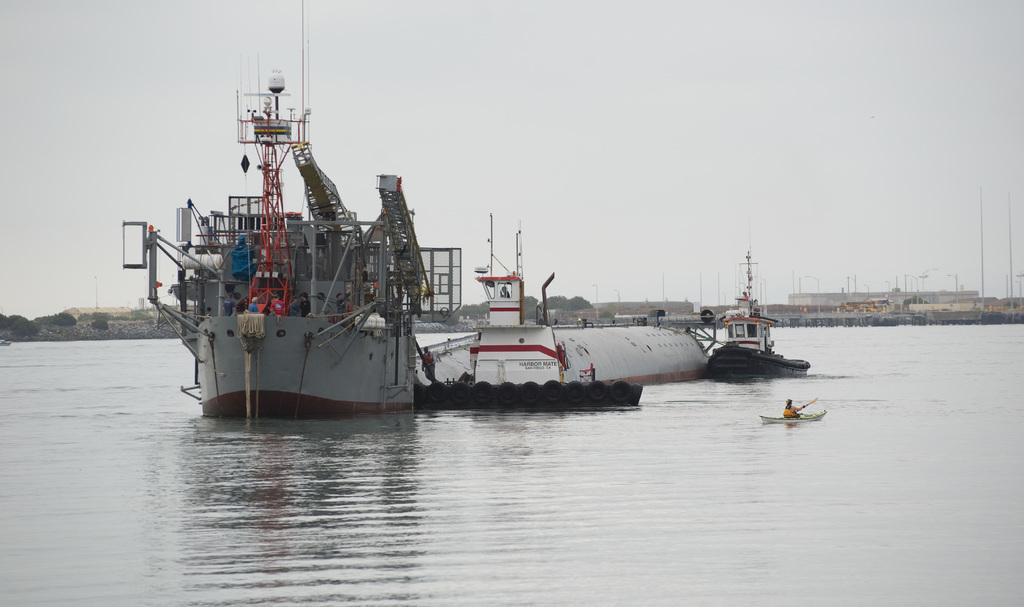What is the main subject of the image? There is a ship in the image. Where is the ship located? The ship is on the water. What can be seen in the background of the image? There are buildings and trees with green color in the background of the image. How is the sky depicted in the image? The sky is visible in the background of the image, and it appears to be white in color. How many roses are on the ship in the image? There are no roses present on the ship in the image. What type of loaf is being served on the ship in the image? There is no loaf present on the ship in the image. 